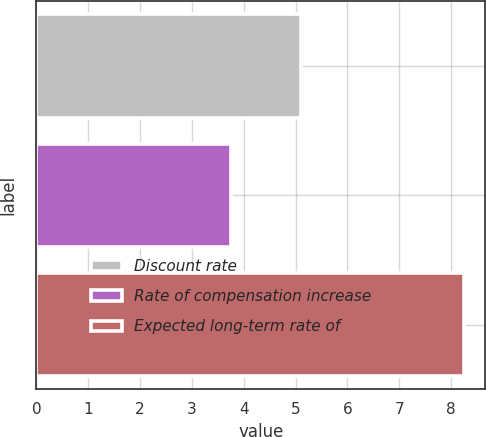Convert chart to OTSL. <chart><loc_0><loc_0><loc_500><loc_500><bar_chart><fcel>Discount rate<fcel>Rate of compensation increase<fcel>Expected long-term rate of<nl><fcel>5.1<fcel>3.75<fcel>8.25<nl></chart> 